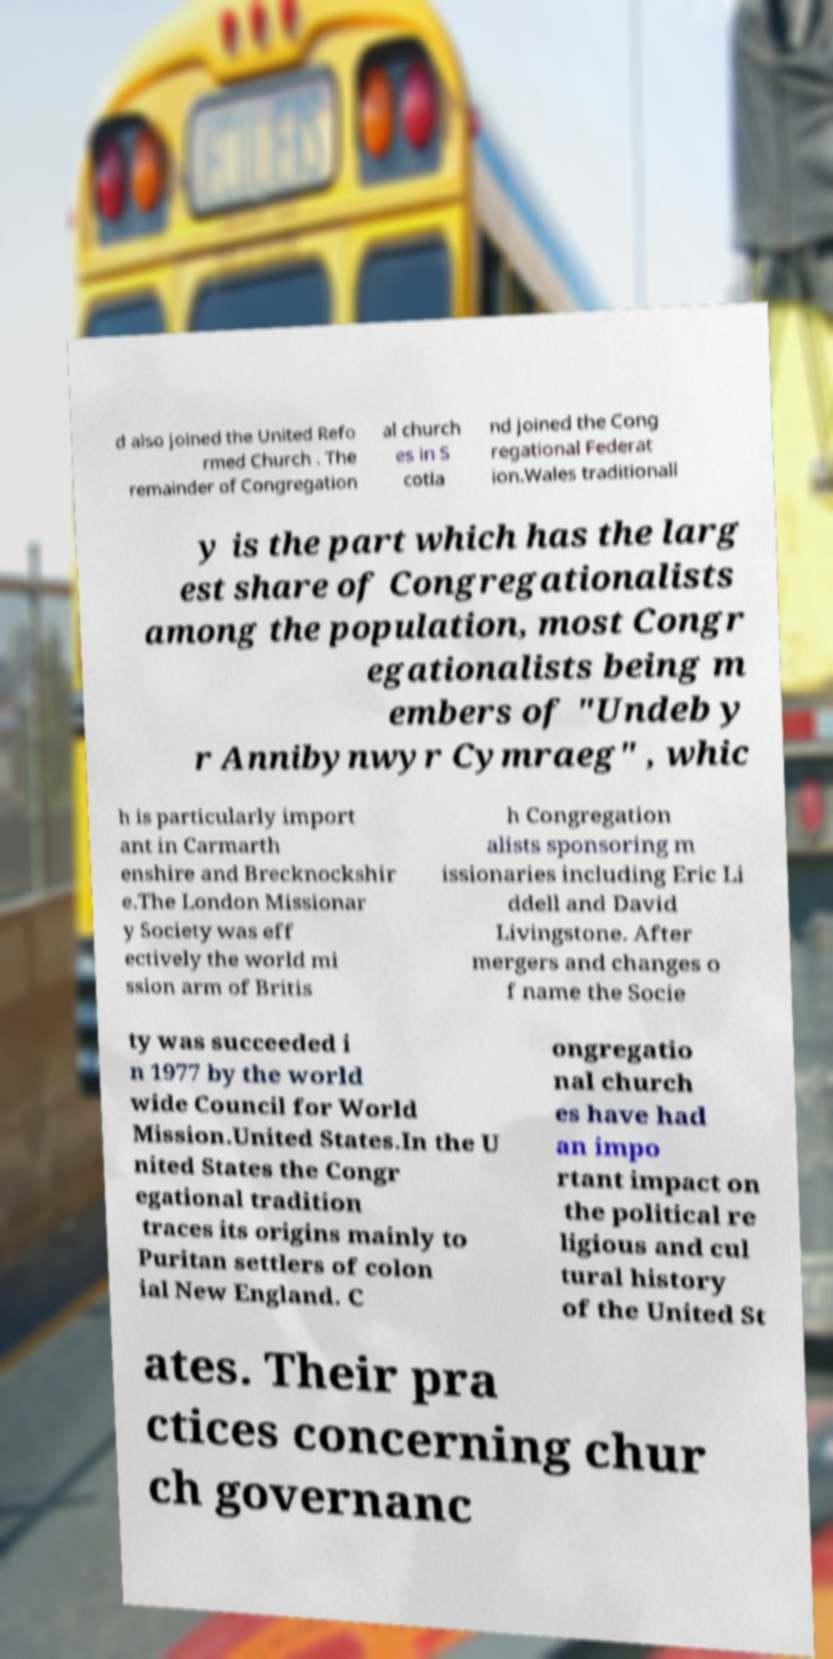Can you accurately transcribe the text from the provided image for me? d also joined the United Refo rmed Church . The remainder of Congregation al church es in S cotla nd joined the Cong regational Federat ion.Wales traditionall y is the part which has the larg est share of Congregationalists among the population, most Congr egationalists being m embers of "Undeb y r Annibynwyr Cymraeg" , whic h is particularly import ant in Carmarth enshire and Brecknockshir e.The London Missionar y Society was eff ectively the world mi ssion arm of Britis h Congregation alists sponsoring m issionaries including Eric Li ddell and David Livingstone. After mergers and changes o f name the Socie ty was succeeded i n 1977 by the world wide Council for World Mission.United States.In the U nited States the Congr egational tradition traces its origins mainly to Puritan settlers of colon ial New England. C ongregatio nal church es have had an impo rtant impact on the political re ligious and cul tural history of the United St ates. Their pra ctices concerning chur ch governanc 